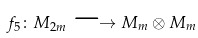Convert formula to latex. <formula><loc_0><loc_0><loc_500><loc_500>f _ { 5 } \colon M _ { 2 m } \longrightarrow M _ { m } \otimes M _ { m }</formula> 